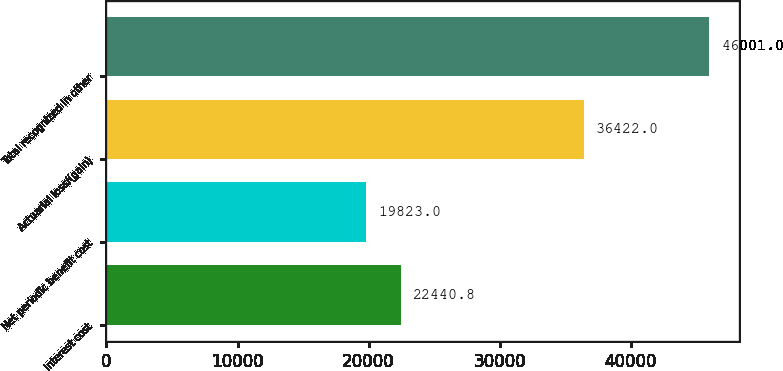Convert chart to OTSL. <chart><loc_0><loc_0><loc_500><loc_500><bar_chart><fcel>Interest cost<fcel>Net periodic benefit cost<fcel>Actuarial loss/(gain)<fcel>Total recognized in other<nl><fcel>22440.8<fcel>19823<fcel>36422<fcel>46001<nl></chart> 